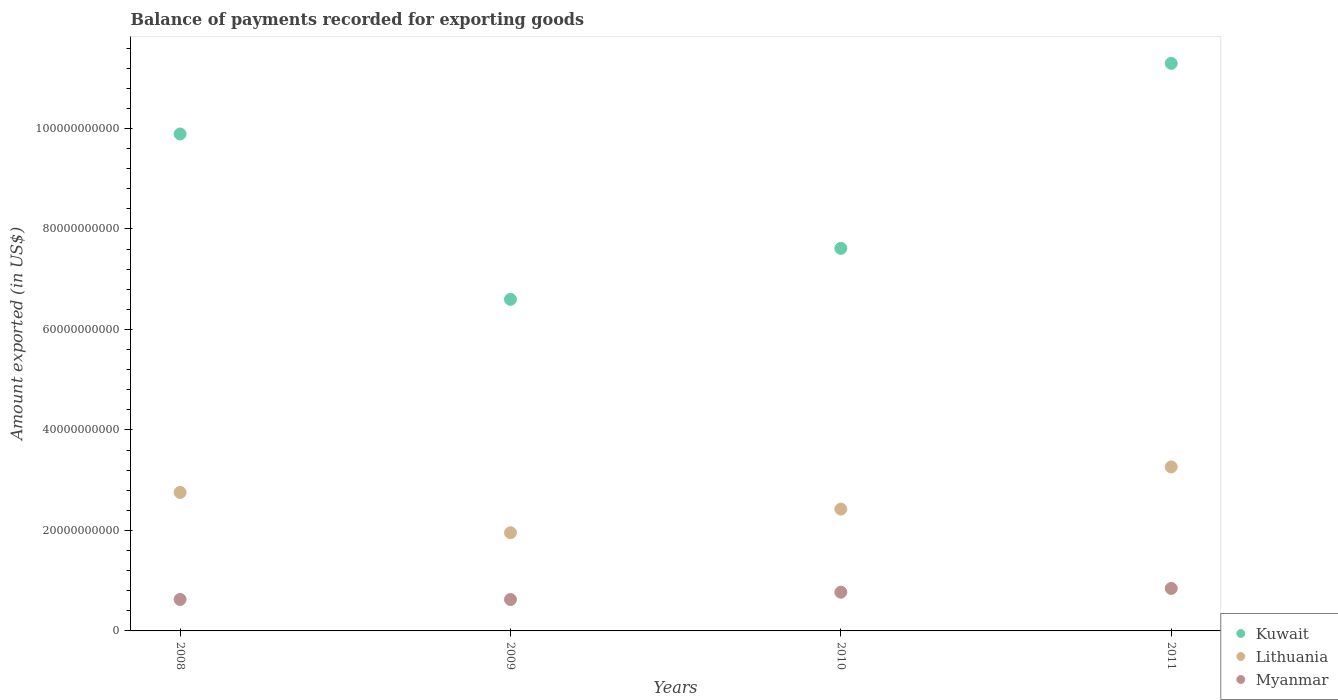How many different coloured dotlines are there?
Provide a short and direct response. 3. What is the amount exported in Kuwait in 2010?
Your response must be concise. 7.61e+1. Across all years, what is the maximum amount exported in Lithuania?
Offer a very short reply. 3.26e+1. Across all years, what is the minimum amount exported in Myanmar?
Your answer should be very brief. 6.25e+09. In which year was the amount exported in Lithuania minimum?
Keep it short and to the point. 2009. What is the total amount exported in Myanmar in the graph?
Your answer should be compact. 2.87e+1. What is the difference between the amount exported in Kuwait in 2008 and that in 2010?
Give a very brief answer. 2.28e+1. What is the difference between the amount exported in Lithuania in 2008 and the amount exported in Kuwait in 2010?
Ensure brevity in your answer.  -4.86e+1. What is the average amount exported in Myanmar per year?
Provide a succinct answer. 7.17e+09. In the year 2010, what is the difference between the amount exported in Kuwait and amount exported in Myanmar?
Make the answer very short. 6.84e+1. What is the ratio of the amount exported in Kuwait in 2008 to that in 2011?
Offer a very short reply. 0.88. Is the amount exported in Kuwait in 2009 less than that in 2010?
Your answer should be compact. Yes. Is the difference between the amount exported in Kuwait in 2008 and 2010 greater than the difference between the amount exported in Myanmar in 2008 and 2010?
Your response must be concise. Yes. What is the difference between the highest and the second highest amount exported in Kuwait?
Provide a succinct answer. 1.40e+1. What is the difference between the highest and the lowest amount exported in Kuwait?
Provide a succinct answer. 4.70e+1. In how many years, is the amount exported in Kuwait greater than the average amount exported in Kuwait taken over all years?
Offer a very short reply. 2. Is the sum of the amount exported in Lithuania in 2009 and 2010 greater than the maximum amount exported in Myanmar across all years?
Make the answer very short. Yes. Is it the case that in every year, the sum of the amount exported in Lithuania and amount exported in Myanmar  is greater than the amount exported in Kuwait?
Your answer should be compact. No. Is the amount exported in Kuwait strictly greater than the amount exported in Lithuania over the years?
Offer a very short reply. Yes. How many dotlines are there?
Offer a very short reply. 3. What is the difference between two consecutive major ticks on the Y-axis?
Provide a succinct answer. 2.00e+1. Does the graph contain grids?
Your answer should be compact. No. Where does the legend appear in the graph?
Your answer should be compact. Bottom right. How many legend labels are there?
Offer a terse response. 3. What is the title of the graph?
Ensure brevity in your answer.  Balance of payments recorded for exporting goods. What is the label or title of the X-axis?
Your answer should be compact. Years. What is the label or title of the Y-axis?
Your answer should be compact. Amount exported (in US$). What is the Amount exported (in US$) in Kuwait in 2008?
Offer a very short reply. 9.89e+1. What is the Amount exported (in US$) of Lithuania in 2008?
Keep it short and to the point. 2.76e+1. What is the Amount exported (in US$) in Myanmar in 2008?
Keep it short and to the point. 6.26e+09. What is the Amount exported (in US$) in Kuwait in 2009?
Provide a short and direct response. 6.60e+1. What is the Amount exported (in US$) in Lithuania in 2009?
Offer a very short reply. 1.95e+1. What is the Amount exported (in US$) of Myanmar in 2009?
Provide a short and direct response. 6.25e+09. What is the Amount exported (in US$) of Kuwait in 2010?
Your response must be concise. 7.61e+1. What is the Amount exported (in US$) in Lithuania in 2010?
Ensure brevity in your answer.  2.42e+1. What is the Amount exported (in US$) of Myanmar in 2010?
Give a very brief answer. 7.70e+09. What is the Amount exported (in US$) of Kuwait in 2011?
Your answer should be compact. 1.13e+11. What is the Amount exported (in US$) of Lithuania in 2011?
Your response must be concise. 3.26e+1. What is the Amount exported (in US$) of Myanmar in 2011?
Offer a terse response. 8.46e+09. Across all years, what is the maximum Amount exported (in US$) in Kuwait?
Make the answer very short. 1.13e+11. Across all years, what is the maximum Amount exported (in US$) of Lithuania?
Your response must be concise. 3.26e+1. Across all years, what is the maximum Amount exported (in US$) in Myanmar?
Your answer should be compact. 8.46e+09. Across all years, what is the minimum Amount exported (in US$) of Kuwait?
Provide a short and direct response. 6.60e+1. Across all years, what is the minimum Amount exported (in US$) of Lithuania?
Your answer should be very brief. 1.95e+1. Across all years, what is the minimum Amount exported (in US$) of Myanmar?
Your answer should be very brief. 6.25e+09. What is the total Amount exported (in US$) of Kuwait in the graph?
Provide a succinct answer. 3.54e+11. What is the total Amount exported (in US$) in Lithuania in the graph?
Provide a succinct answer. 1.04e+11. What is the total Amount exported (in US$) of Myanmar in the graph?
Offer a very short reply. 2.87e+1. What is the difference between the Amount exported (in US$) in Kuwait in 2008 and that in 2009?
Make the answer very short. 3.29e+1. What is the difference between the Amount exported (in US$) of Lithuania in 2008 and that in 2009?
Ensure brevity in your answer.  8.03e+09. What is the difference between the Amount exported (in US$) in Myanmar in 2008 and that in 2009?
Offer a terse response. 9.44e+06. What is the difference between the Amount exported (in US$) in Kuwait in 2008 and that in 2010?
Ensure brevity in your answer.  2.28e+1. What is the difference between the Amount exported (in US$) in Lithuania in 2008 and that in 2010?
Give a very brief answer. 3.32e+09. What is the difference between the Amount exported (in US$) in Myanmar in 2008 and that in 2010?
Your response must be concise. -1.44e+09. What is the difference between the Amount exported (in US$) of Kuwait in 2008 and that in 2011?
Your response must be concise. -1.40e+1. What is the difference between the Amount exported (in US$) in Lithuania in 2008 and that in 2011?
Provide a succinct answer. -5.07e+09. What is the difference between the Amount exported (in US$) of Myanmar in 2008 and that in 2011?
Provide a short and direct response. -2.20e+09. What is the difference between the Amount exported (in US$) of Kuwait in 2009 and that in 2010?
Your answer should be very brief. -1.01e+1. What is the difference between the Amount exported (in US$) in Lithuania in 2009 and that in 2010?
Provide a succinct answer. -4.71e+09. What is the difference between the Amount exported (in US$) in Myanmar in 2009 and that in 2010?
Give a very brief answer. -1.45e+09. What is the difference between the Amount exported (in US$) in Kuwait in 2009 and that in 2011?
Your answer should be compact. -4.70e+1. What is the difference between the Amount exported (in US$) in Lithuania in 2009 and that in 2011?
Keep it short and to the point. -1.31e+1. What is the difference between the Amount exported (in US$) in Myanmar in 2009 and that in 2011?
Give a very brief answer. -2.20e+09. What is the difference between the Amount exported (in US$) in Kuwait in 2010 and that in 2011?
Your answer should be very brief. -3.68e+1. What is the difference between the Amount exported (in US$) of Lithuania in 2010 and that in 2011?
Your answer should be compact. -8.39e+09. What is the difference between the Amount exported (in US$) of Myanmar in 2010 and that in 2011?
Keep it short and to the point. -7.54e+08. What is the difference between the Amount exported (in US$) in Kuwait in 2008 and the Amount exported (in US$) in Lithuania in 2009?
Provide a succinct answer. 7.94e+1. What is the difference between the Amount exported (in US$) of Kuwait in 2008 and the Amount exported (in US$) of Myanmar in 2009?
Ensure brevity in your answer.  9.27e+1. What is the difference between the Amount exported (in US$) of Lithuania in 2008 and the Amount exported (in US$) of Myanmar in 2009?
Offer a very short reply. 2.13e+1. What is the difference between the Amount exported (in US$) of Kuwait in 2008 and the Amount exported (in US$) of Lithuania in 2010?
Your answer should be very brief. 7.47e+1. What is the difference between the Amount exported (in US$) of Kuwait in 2008 and the Amount exported (in US$) of Myanmar in 2010?
Make the answer very short. 9.12e+1. What is the difference between the Amount exported (in US$) in Lithuania in 2008 and the Amount exported (in US$) in Myanmar in 2010?
Offer a very short reply. 1.99e+1. What is the difference between the Amount exported (in US$) in Kuwait in 2008 and the Amount exported (in US$) in Lithuania in 2011?
Provide a short and direct response. 6.63e+1. What is the difference between the Amount exported (in US$) in Kuwait in 2008 and the Amount exported (in US$) in Myanmar in 2011?
Make the answer very short. 9.04e+1. What is the difference between the Amount exported (in US$) of Lithuania in 2008 and the Amount exported (in US$) of Myanmar in 2011?
Offer a terse response. 1.91e+1. What is the difference between the Amount exported (in US$) of Kuwait in 2009 and the Amount exported (in US$) of Lithuania in 2010?
Your answer should be compact. 4.17e+1. What is the difference between the Amount exported (in US$) in Kuwait in 2009 and the Amount exported (in US$) in Myanmar in 2010?
Offer a terse response. 5.83e+1. What is the difference between the Amount exported (in US$) in Lithuania in 2009 and the Amount exported (in US$) in Myanmar in 2010?
Your answer should be very brief. 1.18e+1. What is the difference between the Amount exported (in US$) of Kuwait in 2009 and the Amount exported (in US$) of Lithuania in 2011?
Provide a short and direct response. 3.34e+1. What is the difference between the Amount exported (in US$) in Kuwait in 2009 and the Amount exported (in US$) in Myanmar in 2011?
Your answer should be compact. 5.75e+1. What is the difference between the Amount exported (in US$) in Lithuania in 2009 and the Amount exported (in US$) in Myanmar in 2011?
Offer a very short reply. 1.11e+1. What is the difference between the Amount exported (in US$) of Kuwait in 2010 and the Amount exported (in US$) of Lithuania in 2011?
Make the answer very short. 4.35e+1. What is the difference between the Amount exported (in US$) of Kuwait in 2010 and the Amount exported (in US$) of Myanmar in 2011?
Keep it short and to the point. 6.77e+1. What is the difference between the Amount exported (in US$) in Lithuania in 2010 and the Amount exported (in US$) in Myanmar in 2011?
Provide a short and direct response. 1.58e+1. What is the average Amount exported (in US$) of Kuwait per year?
Keep it short and to the point. 8.85e+1. What is the average Amount exported (in US$) of Lithuania per year?
Provide a succinct answer. 2.60e+1. What is the average Amount exported (in US$) of Myanmar per year?
Offer a very short reply. 7.17e+09. In the year 2008, what is the difference between the Amount exported (in US$) in Kuwait and Amount exported (in US$) in Lithuania?
Make the answer very short. 7.13e+1. In the year 2008, what is the difference between the Amount exported (in US$) in Kuwait and Amount exported (in US$) in Myanmar?
Your answer should be very brief. 9.26e+1. In the year 2008, what is the difference between the Amount exported (in US$) of Lithuania and Amount exported (in US$) of Myanmar?
Ensure brevity in your answer.  2.13e+1. In the year 2009, what is the difference between the Amount exported (in US$) in Kuwait and Amount exported (in US$) in Lithuania?
Offer a terse response. 4.65e+1. In the year 2009, what is the difference between the Amount exported (in US$) in Kuwait and Amount exported (in US$) in Myanmar?
Keep it short and to the point. 5.97e+1. In the year 2009, what is the difference between the Amount exported (in US$) in Lithuania and Amount exported (in US$) in Myanmar?
Your response must be concise. 1.33e+1. In the year 2010, what is the difference between the Amount exported (in US$) of Kuwait and Amount exported (in US$) of Lithuania?
Offer a terse response. 5.19e+1. In the year 2010, what is the difference between the Amount exported (in US$) in Kuwait and Amount exported (in US$) in Myanmar?
Ensure brevity in your answer.  6.84e+1. In the year 2010, what is the difference between the Amount exported (in US$) in Lithuania and Amount exported (in US$) in Myanmar?
Offer a very short reply. 1.65e+1. In the year 2011, what is the difference between the Amount exported (in US$) of Kuwait and Amount exported (in US$) of Lithuania?
Ensure brevity in your answer.  8.03e+1. In the year 2011, what is the difference between the Amount exported (in US$) in Kuwait and Amount exported (in US$) in Myanmar?
Ensure brevity in your answer.  1.04e+11. In the year 2011, what is the difference between the Amount exported (in US$) in Lithuania and Amount exported (in US$) in Myanmar?
Provide a short and direct response. 2.42e+1. What is the ratio of the Amount exported (in US$) in Kuwait in 2008 to that in 2009?
Offer a terse response. 1.5. What is the ratio of the Amount exported (in US$) in Lithuania in 2008 to that in 2009?
Your answer should be compact. 1.41. What is the ratio of the Amount exported (in US$) of Myanmar in 2008 to that in 2009?
Offer a very short reply. 1. What is the ratio of the Amount exported (in US$) in Kuwait in 2008 to that in 2010?
Your answer should be compact. 1.3. What is the ratio of the Amount exported (in US$) of Lithuania in 2008 to that in 2010?
Provide a short and direct response. 1.14. What is the ratio of the Amount exported (in US$) in Myanmar in 2008 to that in 2010?
Keep it short and to the point. 0.81. What is the ratio of the Amount exported (in US$) of Kuwait in 2008 to that in 2011?
Offer a terse response. 0.88. What is the ratio of the Amount exported (in US$) of Lithuania in 2008 to that in 2011?
Your answer should be very brief. 0.84. What is the ratio of the Amount exported (in US$) of Myanmar in 2008 to that in 2011?
Provide a short and direct response. 0.74. What is the ratio of the Amount exported (in US$) in Kuwait in 2009 to that in 2010?
Offer a terse response. 0.87. What is the ratio of the Amount exported (in US$) of Lithuania in 2009 to that in 2010?
Keep it short and to the point. 0.81. What is the ratio of the Amount exported (in US$) in Myanmar in 2009 to that in 2010?
Your response must be concise. 0.81. What is the ratio of the Amount exported (in US$) in Kuwait in 2009 to that in 2011?
Your answer should be very brief. 0.58. What is the ratio of the Amount exported (in US$) of Lithuania in 2009 to that in 2011?
Offer a very short reply. 0.6. What is the ratio of the Amount exported (in US$) in Myanmar in 2009 to that in 2011?
Offer a very short reply. 0.74. What is the ratio of the Amount exported (in US$) of Kuwait in 2010 to that in 2011?
Keep it short and to the point. 0.67. What is the ratio of the Amount exported (in US$) in Lithuania in 2010 to that in 2011?
Give a very brief answer. 0.74. What is the ratio of the Amount exported (in US$) in Myanmar in 2010 to that in 2011?
Keep it short and to the point. 0.91. What is the difference between the highest and the second highest Amount exported (in US$) in Kuwait?
Your answer should be very brief. 1.40e+1. What is the difference between the highest and the second highest Amount exported (in US$) in Lithuania?
Offer a very short reply. 5.07e+09. What is the difference between the highest and the second highest Amount exported (in US$) in Myanmar?
Provide a short and direct response. 7.54e+08. What is the difference between the highest and the lowest Amount exported (in US$) of Kuwait?
Provide a short and direct response. 4.70e+1. What is the difference between the highest and the lowest Amount exported (in US$) of Lithuania?
Your answer should be compact. 1.31e+1. What is the difference between the highest and the lowest Amount exported (in US$) of Myanmar?
Provide a succinct answer. 2.20e+09. 